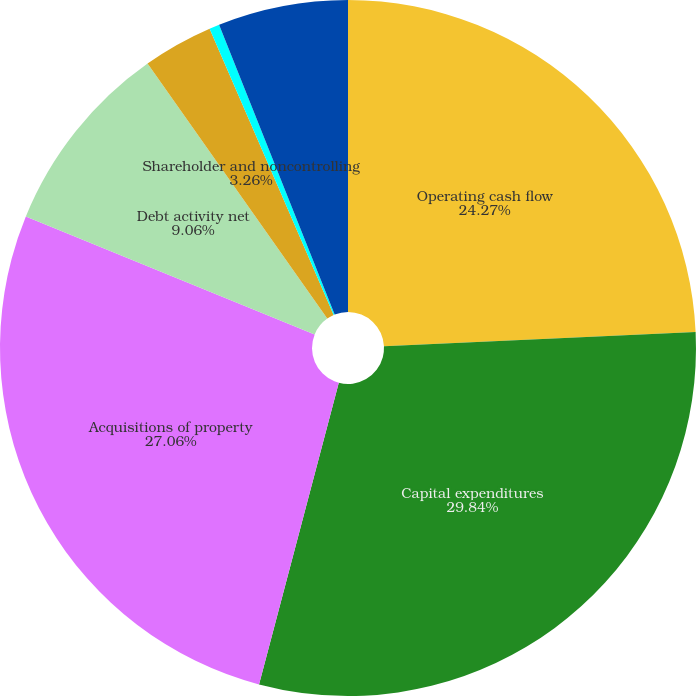Convert chart. <chart><loc_0><loc_0><loc_500><loc_500><pie_chart><fcel>Operating cash flow<fcel>Capital expenditures<fcel>Acquisitions of property<fcel>Debt activity net<fcel>Shareholder and noncontrolling<fcel>Effect of exchange rate and<fcel>Cash and cash equivalents at<nl><fcel>24.27%<fcel>29.85%<fcel>27.06%<fcel>9.06%<fcel>3.26%<fcel>0.47%<fcel>6.04%<nl></chart> 